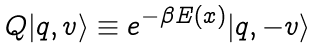<formula> <loc_0><loc_0><loc_500><loc_500>Q | q , v \rangle \equiv e ^ { - \beta E ( { \boldmath x } ) } | q , - v \rangle</formula> 